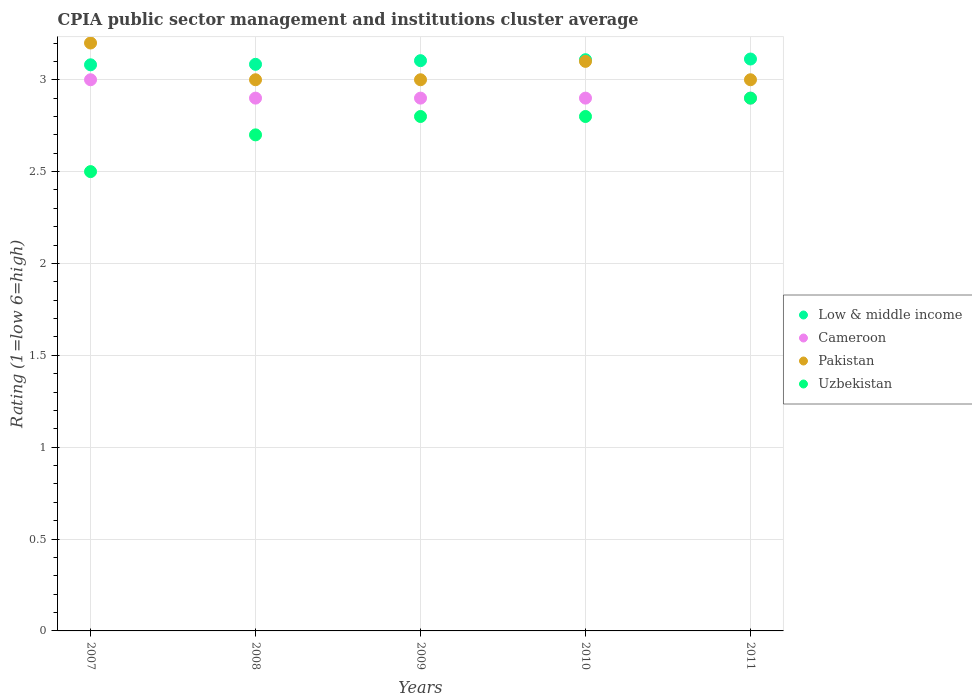What is the CPIA rating in Cameroon in 2010?
Provide a succinct answer. 2.9. Across all years, what is the minimum CPIA rating in Low & middle income?
Give a very brief answer. 3.08. What is the total CPIA rating in Cameroon in the graph?
Provide a succinct answer. 14.6. What is the difference between the CPIA rating in Cameroon in 2011 and the CPIA rating in Low & middle income in 2008?
Ensure brevity in your answer.  -0.18. What is the average CPIA rating in Low & middle income per year?
Keep it short and to the point. 3.1. In the year 2011, what is the difference between the CPIA rating in Low & middle income and CPIA rating in Pakistan?
Ensure brevity in your answer.  0.11. What is the ratio of the CPIA rating in Uzbekistan in 2008 to that in 2011?
Provide a succinct answer. 0.93. Is the difference between the CPIA rating in Low & middle income in 2007 and 2009 greater than the difference between the CPIA rating in Pakistan in 2007 and 2009?
Offer a very short reply. No. What is the difference between the highest and the second highest CPIA rating in Pakistan?
Provide a short and direct response. 0.1. What is the difference between the highest and the lowest CPIA rating in Uzbekistan?
Your answer should be very brief. 0.4. Is it the case that in every year, the sum of the CPIA rating in Pakistan and CPIA rating in Cameroon  is greater than the CPIA rating in Low & middle income?
Offer a very short reply. Yes. Are the values on the major ticks of Y-axis written in scientific E-notation?
Give a very brief answer. No. Does the graph contain any zero values?
Provide a succinct answer. No. Where does the legend appear in the graph?
Ensure brevity in your answer.  Center right. How many legend labels are there?
Keep it short and to the point. 4. How are the legend labels stacked?
Provide a short and direct response. Vertical. What is the title of the graph?
Provide a short and direct response. CPIA public sector management and institutions cluster average. Does "Grenada" appear as one of the legend labels in the graph?
Ensure brevity in your answer.  No. What is the label or title of the X-axis?
Keep it short and to the point. Years. What is the label or title of the Y-axis?
Provide a succinct answer. Rating (1=low 6=high). What is the Rating (1=low 6=high) of Low & middle income in 2007?
Provide a short and direct response. 3.08. What is the Rating (1=low 6=high) of Pakistan in 2007?
Offer a terse response. 3.2. What is the Rating (1=low 6=high) of Uzbekistan in 2007?
Make the answer very short. 2.5. What is the Rating (1=low 6=high) in Low & middle income in 2008?
Make the answer very short. 3.08. What is the Rating (1=low 6=high) in Cameroon in 2008?
Offer a terse response. 2.9. What is the Rating (1=low 6=high) in Pakistan in 2008?
Offer a very short reply. 3. What is the Rating (1=low 6=high) in Uzbekistan in 2008?
Provide a succinct answer. 2.7. What is the Rating (1=low 6=high) in Low & middle income in 2009?
Make the answer very short. 3.1. What is the Rating (1=low 6=high) of Cameroon in 2009?
Ensure brevity in your answer.  2.9. What is the Rating (1=low 6=high) in Low & middle income in 2010?
Offer a very short reply. 3.11. What is the Rating (1=low 6=high) in Cameroon in 2010?
Offer a very short reply. 2.9. What is the Rating (1=low 6=high) of Pakistan in 2010?
Make the answer very short. 3.1. What is the Rating (1=low 6=high) of Low & middle income in 2011?
Make the answer very short. 3.11. What is the Rating (1=low 6=high) of Pakistan in 2011?
Offer a very short reply. 3. What is the Rating (1=low 6=high) of Uzbekistan in 2011?
Your answer should be compact. 2.9. Across all years, what is the maximum Rating (1=low 6=high) of Low & middle income?
Provide a succinct answer. 3.11. Across all years, what is the maximum Rating (1=low 6=high) of Cameroon?
Your answer should be compact. 3. Across all years, what is the maximum Rating (1=low 6=high) of Pakistan?
Ensure brevity in your answer.  3.2. Across all years, what is the minimum Rating (1=low 6=high) in Low & middle income?
Your answer should be very brief. 3.08. Across all years, what is the minimum Rating (1=low 6=high) in Cameroon?
Provide a short and direct response. 2.9. What is the total Rating (1=low 6=high) of Low & middle income in the graph?
Give a very brief answer. 15.49. What is the total Rating (1=low 6=high) of Uzbekistan in the graph?
Your answer should be very brief. 13.7. What is the difference between the Rating (1=low 6=high) of Low & middle income in 2007 and that in 2008?
Ensure brevity in your answer.  -0. What is the difference between the Rating (1=low 6=high) of Cameroon in 2007 and that in 2008?
Offer a very short reply. 0.1. What is the difference between the Rating (1=low 6=high) of Pakistan in 2007 and that in 2008?
Offer a terse response. 0.2. What is the difference between the Rating (1=low 6=high) in Low & middle income in 2007 and that in 2009?
Ensure brevity in your answer.  -0.02. What is the difference between the Rating (1=low 6=high) in Low & middle income in 2007 and that in 2010?
Keep it short and to the point. -0.03. What is the difference between the Rating (1=low 6=high) of Uzbekistan in 2007 and that in 2010?
Provide a short and direct response. -0.3. What is the difference between the Rating (1=low 6=high) of Low & middle income in 2007 and that in 2011?
Give a very brief answer. -0.03. What is the difference between the Rating (1=low 6=high) in Uzbekistan in 2007 and that in 2011?
Offer a very short reply. -0.4. What is the difference between the Rating (1=low 6=high) of Low & middle income in 2008 and that in 2009?
Offer a terse response. -0.02. What is the difference between the Rating (1=low 6=high) of Cameroon in 2008 and that in 2009?
Offer a very short reply. 0. What is the difference between the Rating (1=low 6=high) of Low & middle income in 2008 and that in 2010?
Your answer should be compact. -0.03. What is the difference between the Rating (1=low 6=high) of Cameroon in 2008 and that in 2010?
Keep it short and to the point. 0. What is the difference between the Rating (1=low 6=high) of Pakistan in 2008 and that in 2010?
Ensure brevity in your answer.  -0.1. What is the difference between the Rating (1=low 6=high) in Uzbekistan in 2008 and that in 2010?
Your answer should be very brief. -0.1. What is the difference between the Rating (1=low 6=high) in Low & middle income in 2008 and that in 2011?
Your response must be concise. -0.03. What is the difference between the Rating (1=low 6=high) of Cameroon in 2008 and that in 2011?
Ensure brevity in your answer.  0. What is the difference between the Rating (1=low 6=high) of Low & middle income in 2009 and that in 2010?
Your answer should be very brief. -0.01. What is the difference between the Rating (1=low 6=high) in Cameroon in 2009 and that in 2010?
Offer a terse response. 0. What is the difference between the Rating (1=low 6=high) in Uzbekistan in 2009 and that in 2010?
Your answer should be very brief. 0. What is the difference between the Rating (1=low 6=high) of Low & middle income in 2009 and that in 2011?
Your answer should be very brief. -0.01. What is the difference between the Rating (1=low 6=high) of Cameroon in 2009 and that in 2011?
Ensure brevity in your answer.  0. What is the difference between the Rating (1=low 6=high) of Uzbekistan in 2009 and that in 2011?
Your response must be concise. -0.1. What is the difference between the Rating (1=low 6=high) of Low & middle income in 2010 and that in 2011?
Make the answer very short. -0. What is the difference between the Rating (1=low 6=high) of Cameroon in 2010 and that in 2011?
Ensure brevity in your answer.  0. What is the difference between the Rating (1=low 6=high) in Pakistan in 2010 and that in 2011?
Your answer should be compact. 0.1. What is the difference between the Rating (1=low 6=high) of Uzbekistan in 2010 and that in 2011?
Your answer should be compact. -0.1. What is the difference between the Rating (1=low 6=high) in Low & middle income in 2007 and the Rating (1=low 6=high) in Cameroon in 2008?
Provide a short and direct response. 0.18. What is the difference between the Rating (1=low 6=high) of Low & middle income in 2007 and the Rating (1=low 6=high) of Pakistan in 2008?
Offer a very short reply. 0.08. What is the difference between the Rating (1=low 6=high) of Low & middle income in 2007 and the Rating (1=low 6=high) of Uzbekistan in 2008?
Provide a succinct answer. 0.38. What is the difference between the Rating (1=low 6=high) in Low & middle income in 2007 and the Rating (1=low 6=high) in Cameroon in 2009?
Provide a succinct answer. 0.18. What is the difference between the Rating (1=low 6=high) in Low & middle income in 2007 and the Rating (1=low 6=high) in Pakistan in 2009?
Ensure brevity in your answer.  0.08. What is the difference between the Rating (1=low 6=high) in Low & middle income in 2007 and the Rating (1=low 6=high) in Uzbekistan in 2009?
Make the answer very short. 0.28. What is the difference between the Rating (1=low 6=high) in Low & middle income in 2007 and the Rating (1=low 6=high) in Cameroon in 2010?
Give a very brief answer. 0.18. What is the difference between the Rating (1=low 6=high) in Low & middle income in 2007 and the Rating (1=low 6=high) in Pakistan in 2010?
Your answer should be compact. -0.02. What is the difference between the Rating (1=low 6=high) of Low & middle income in 2007 and the Rating (1=low 6=high) of Uzbekistan in 2010?
Provide a succinct answer. 0.28. What is the difference between the Rating (1=low 6=high) of Cameroon in 2007 and the Rating (1=low 6=high) of Uzbekistan in 2010?
Your answer should be very brief. 0.2. What is the difference between the Rating (1=low 6=high) of Low & middle income in 2007 and the Rating (1=low 6=high) of Cameroon in 2011?
Your answer should be very brief. 0.18. What is the difference between the Rating (1=low 6=high) of Low & middle income in 2007 and the Rating (1=low 6=high) of Pakistan in 2011?
Make the answer very short. 0.08. What is the difference between the Rating (1=low 6=high) of Low & middle income in 2007 and the Rating (1=low 6=high) of Uzbekistan in 2011?
Your answer should be very brief. 0.18. What is the difference between the Rating (1=low 6=high) of Cameroon in 2007 and the Rating (1=low 6=high) of Pakistan in 2011?
Give a very brief answer. 0. What is the difference between the Rating (1=low 6=high) in Cameroon in 2007 and the Rating (1=low 6=high) in Uzbekistan in 2011?
Offer a very short reply. 0.1. What is the difference between the Rating (1=low 6=high) in Pakistan in 2007 and the Rating (1=low 6=high) in Uzbekistan in 2011?
Your answer should be very brief. 0.3. What is the difference between the Rating (1=low 6=high) in Low & middle income in 2008 and the Rating (1=low 6=high) in Cameroon in 2009?
Your answer should be compact. 0.18. What is the difference between the Rating (1=low 6=high) in Low & middle income in 2008 and the Rating (1=low 6=high) in Pakistan in 2009?
Your answer should be compact. 0.08. What is the difference between the Rating (1=low 6=high) of Low & middle income in 2008 and the Rating (1=low 6=high) of Uzbekistan in 2009?
Ensure brevity in your answer.  0.28. What is the difference between the Rating (1=low 6=high) in Low & middle income in 2008 and the Rating (1=low 6=high) in Cameroon in 2010?
Provide a short and direct response. 0.18. What is the difference between the Rating (1=low 6=high) in Low & middle income in 2008 and the Rating (1=low 6=high) in Pakistan in 2010?
Give a very brief answer. -0.02. What is the difference between the Rating (1=low 6=high) of Low & middle income in 2008 and the Rating (1=low 6=high) of Uzbekistan in 2010?
Provide a short and direct response. 0.28. What is the difference between the Rating (1=low 6=high) in Cameroon in 2008 and the Rating (1=low 6=high) in Pakistan in 2010?
Give a very brief answer. -0.2. What is the difference between the Rating (1=low 6=high) of Cameroon in 2008 and the Rating (1=low 6=high) of Uzbekistan in 2010?
Provide a succinct answer. 0.1. What is the difference between the Rating (1=low 6=high) in Pakistan in 2008 and the Rating (1=low 6=high) in Uzbekistan in 2010?
Give a very brief answer. 0.2. What is the difference between the Rating (1=low 6=high) in Low & middle income in 2008 and the Rating (1=low 6=high) in Cameroon in 2011?
Your response must be concise. 0.18. What is the difference between the Rating (1=low 6=high) of Low & middle income in 2008 and the Rating (1=low 6=high) of Pakistan in 2011?
Offer a very short reply. 0.08. What is the difference between the Rating (1=low 6=high) in Low & middle income in 2008 and the Rating (1=low 6=high) in Uzbekistan in 2011?
Your answer should be very brief. 0.18. What is the difference between the Rating (1=low 6=high) in Cameroon in 2008 and the Rating (1=low 6=high) in Pakistan in 2011?
Provide a short and direct response. -0.1. What is the difference between the Rating (1=low 6=high) in Low & middle income in 2009 and the Rating (1=low 6=high) in Cameroon in 2010?
Keep it short and to the point. 0.2. What is the difference between the Rating (1=low 6=high) in Low & middle income in 2009 and the Rating (1=low 6=high) in Pakistan in 2010?
Offer a very short reply. 0. What is the difference between the Rating (1=low 6=high) of Low & middle income in 2009 and the Rating (1=low 6=high) of Uzbekistan in 2010?
Ensure brevity in your answer.  0.3. What is the difference between the Rating (1=low 6=high) of Pakistan in 2009 and the Rating (1=low 6=high) of Uzbekistan in 2010?
Your answer should be compact. 0.2. What is the difference between the Rating (1=low 6=high) in Low & middle income in 2009 and the Rating (1=low 6=high) in Cameroon in 2011?
Keep it short and to the point. 0.2. What is the difference between the Rating (1=low 6=high) in Low & middle income in 2009 and the Rating (1=low 6=high) in Pakistan in 2011?
Your answer should be very brief. 0.1. What is the difference between the Rating (1=low 6=high) in Low & middle income in 2009 and the Rating (1=low 6=high) in Uzbekistan in 2011?
Provide a succinct answer. 0.2. What is the difference between the Rating (1=low 6=high) of Low & middle income in 2010 and the Rating (1=low 6=high) of Cameroon in 2011?
Make the answer very short. 0.21. What is the difference between the Rating (1=low 6=high) of Low & middle income in 2010 and the Rating (1=low 6=high) of Pakistan in 2011?
Offer a very short reply. 0.11. What is the difference between the Rating (1=low 6=high) of Low & middle income in 2010 and the Rating (1=low 6=high) of Uzbekistan in 2011?
Your response must be concise. 0.21. What is the difference between the Rating (1=low 6=high) of Cameroon in 2010 and the Rating (1=low 6=high) of Uzbekistan in 2011?
Keep it short and to the point. 0. What is the difference between the Rating (1=low 6=high) in Pakistan in 2010 and the Rating (1=low 6=high) in Uzbekistan in 2011?
Offer a terse response. 0.2. What is the average Rating (1=low 6=high) in Low & middle income per year?
Make the answer very short. 3.1. What is the average Rating (1=low 6=high) in Cameroon per year?
Make the answer very short. 2.92. What is the average Rating (1=low 6=high) of Pakistan per year?
Ensure brevity in your answer.  3.06. What is the average Rating (1=low 6=high) of Uzbekistan per year?
Give a very brief answer. 2.74. In the year 2007, what is the difference between the Rating (1=low 6=high) in Low & middle income and Rating (1=low 6=high) in Cameroon?
Provide a succinct answer. 0.08. In the year 2007, what is the difference between the Rating (1=low 6=high) in Low & middle income and Rating (1=low 6=high) in Pakistan?
Your answer should be compact. -0.12. In the year 2007, what is the difference between the Rating (1=low 6=high) of Low & middle income and Rating (1=low 6=high) of Uzbekistan?
Give a very brief answer. 0.58. In the year 2007, what is the difference between the Rating (1=low 6=high) in Cameroon and Rating (1=low 6=high) in Pakistan?
Offer a very short reply. -0.2. In the year 2007, what is the difference between the Rating (1=low 6=high) in Cameroon and Rating (1=low 6=high) in Uzbekistan?
Offer a very short reply. 0.5. In the year 2007, what is the difference between the Rating (1=low 6=high) of Pakistan and Rating (1=low 6=high) of Uzbekistan?
Provide a short and direct response. 0.7. In the year 2008, what is the difference between the Rating (1=low 6=high) in Low & middle income and Rating (1=low 6=high) in Cameroon?
Provide a short and direct response. 0.18. In the year 2008, what is the difference between the Rating (1=low 6=high) in Low & middle income and Rating (1=low 6=high) in Pakistan?
Give a very brief answer. 0.08. In the year 2008, what is the difference between the Rating (1=low 6=high) in Low & middle income and Rating (1=low 6=high) in Uzbekistan?
Your response must be concise. 0.38. In the year 2008, what is the difference between the Rating (1=low 6=high) in Cameroon and Rating (1=low 6=high) in Pakistan?
Make the answer very short. -0.1. In the year 2008, what is the difference between the Rating (1=low 6=high) of Cameroon and Rating (1=low 6=high) of Uzbekistan?
Give a very brief answer. 0.2. In the year 2008, what is the difference between the Rating (1=low 6=high) in Pakistan and Rating (1=low 6=high) in Uzbekistan?
Offer a very short reply. 0.3. In the year 2009, what is the difference between the Rating (1=low 6=high) in Low & middle income and Rating (1=low 6=high) in Cameroon?
Provide a short and direct response. 0.2. In the year 2009, what is the difference between the Rating (1=low 6=high) in Low & middle income and Rating (1=low 6=high) in Pakistan?
Provide a succinct answer. 0.1. In the year 2009, what is the difference between the Rating (1=low 6=high) in Low & middle income and Rating (1=low 6=high) in Uzbekistan?
Make the answer very short. 0.3. In the year 2009, what is the difference between the Rating (1=low 6=high) of Cameroon and Rating (1=low 6=high) of Pakistan?
Make the answer very short. -0.1. In the year 2009, what is the difference between the Rating (1=low 6=high) in Cameroon and Rating (1=low 6=high) in Uzbekistan?
Make the answer very short. 0.1. In the year 2010, what is the difference between the Rating (1=low 6=high) of Low & middle income and Rating (1=low 6=high) of Cameroon?
Provide a succinct answer. 0.21. In the year 2010, what is the difference between the Rating (1=low 6=high) in Low & middle income and Rating (1=low 6=high) in Pakistan?
Provide a succinct answer. 0.01. In the year 2010, what is the difference between the Rating (1=low 6=high) in Low & middle income and Rating (1=low 6=high) in Uzbekistan?
Provide a short and direct response. 0.31. In the year 2010, what is the difference between the Rating (1=low 6=high) of Cameroon and Rating (1=low 6=high) of Pakistan?
Offer a very short reply. -0.2. In the year 2010, what is the difference between the Rating (1=low 6=high) in Cameroon and Rating (1=low 6=high) in Uzbekistan?
Offer a terse response. 0.1. In the year 2011, what is the difference between the Rating (1=low 6=high) of Low & middle income and Rating (1=low 6=high) of Cameroon?
Your answer should be very brief. 0.21. In the year 2011, what is the difference between the Rating (1=low 6=high) in Low & middle income and Rating (1=low 6=high) in Pakistan?
Your response must be concise. 0.11. In the year 2011, what is the difference between the Rating (1=low 6=high) in Low & middle income and Rating (1=low 6=high) in Uzbekistan?
Offer a very short reply. 0.21. In the year 2011, what is the difference between the Rating (1=low 6=high) of Pakistan and Rating (1=low 6=high) of Uzbekistan?
Keep it short and to the point. 0.1. What is the ratio of the Rating (1=low 6=high) in Cameroon in 2007 to that in 2008?
Your response must be concise. 1.03. What is the ratio of the Rating (1=low 6=high) of Pakistan in 2007 to that in 2008?
Make the answer very short. 1.07. What is the ratio of the Rating (1=low 6=high) of Uzbekistan in 2007 to that in 2008?
Make the answer very short. 0.93. What is the ratio of the Rating (1=low 6=high) in Cameroon in 2007 to that in 2009?
Give a very brief answer. 1.03. What is the ratio of the Rating (1=low 6=high) of Pakistan in 2007 to that in 2009?
Offer a very short reply. 1.07. What is the ratio of the Rating (1=low 6=high) of Uzbekistan in 2007 to that in 2009?
Give a very brief answer. 0.89. What is the ratio of the Rating (1=low 6=high) in Low & middle income in 2007 to that in 2010?
Ensure brevity in your answer.  0.99. What is the ratio of the Rating (1=low 6=high) of Cameroon in 2007 to that in 2010?
Your response must be concise. 1.03. What is the ratio of the Rating (1=low 6=high) in Pakistan in 2007 to that in 2010?
Offer a very short reply. 1.03. What is the ratio of the Rating (1=low 6=high) of Uzbekistan in 2007 to that in 2010?
Offer a terse response. 0.89. What is the ratio of the Rating (1=low 6=high) in Cameroon in 2007 to that in 2011?
Ensure brevity in your answer.  1.03. What is the ratio of the Rating (1=low 6=high) of Pakistan in 2007 to that in 2011?
Offer a terse response. 1.07. What is the ratio of the Rating (1=low 6=high) of Uzbekistan in 2007 to that in 2011?
Provide a short and direct response. 0.86. What is the ratio of the Rating (1=low 6=high) in Low & middle income in 2008 to that in 2009?
Ensure brevity in your answer.  0.99. What is the ratio of the Rating (1=low 6=high) of Cameroon in 2008 to that in 2009?
Your response must be concise. 1. What is the ratio of the Rating (1=low 6=high) in Uzbekistan in 2008 to that in 2010?
Your answer should be compact. 0.96. What is the ratio of the Rating (1=low 6=high) of Cameroon in 2009 to that in 2010?
Offer a very short reply. 1. What is the ratio of the Rating (1=low 6=high) in Uzbekistan in 2009 to that in 2010?
Provide a short and direct response. 1. What is the ratio of the Rating (1=low 6=high) of Low & middle income in 2009 to that in 2011?
Make the answer very short. 1. What is the ratio of the Rating (1=low 6=high) of Cameroon in 2009 to that in 2011?
Give a very brief answer. 1. What is the ratio of the Rating (1=low 6=high) in Pakistan in 2009 to that in 2011?
Provide a succinct answer. 1. What is the ratio of the Rating (1=low 6=high) in Uzbekistan in 2009 to that in 2011?
Offer a terse response. 0.97. What is the ratio of the Rating (1=low 6=high) in Low & middle income in 2010 to that in 2011?
Provide a succinct answer. 1. What is the ratio of the Rating (1=low 6=high) of Cameroon in 2010 to that in 2011?
Keep it short and to the point. 1. What is the ratio of the Rating (1=low 6=high) in Uzbekistan in 2010 to that in 2011?
Ensure brevity in your answer.  0.97. What is the difference between the highest and the second highest Rating (1=low 6=high) in Low & middle income?
Give a very brief answer. 0. What is the difference between the highest and the second highest Rating (1=low 6=high) in Pakistan?
Provide a succinct answer. 0.1. What is the difference between the highest and the lowest Rating (1=low 6=high) in Low & middle income?
Your answer should be very brief. 0.03. 